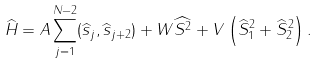Convert formula to latex. <formula><loc_0><loc_0><loc_500><loc_500>\widehat { H } = A \sum _ { j = 1 } ^ { N - 2 } ( \widehat { s } _ { j } , \widehat { s } _ { j + 2 } ) + W \widehat { S ^ { 2 } } + V \left ( \widehat { S } ^ { 2 } _ { 1 } + \widehat { S } ^ { 2 } _ { 2 } \right ) .</formula> 